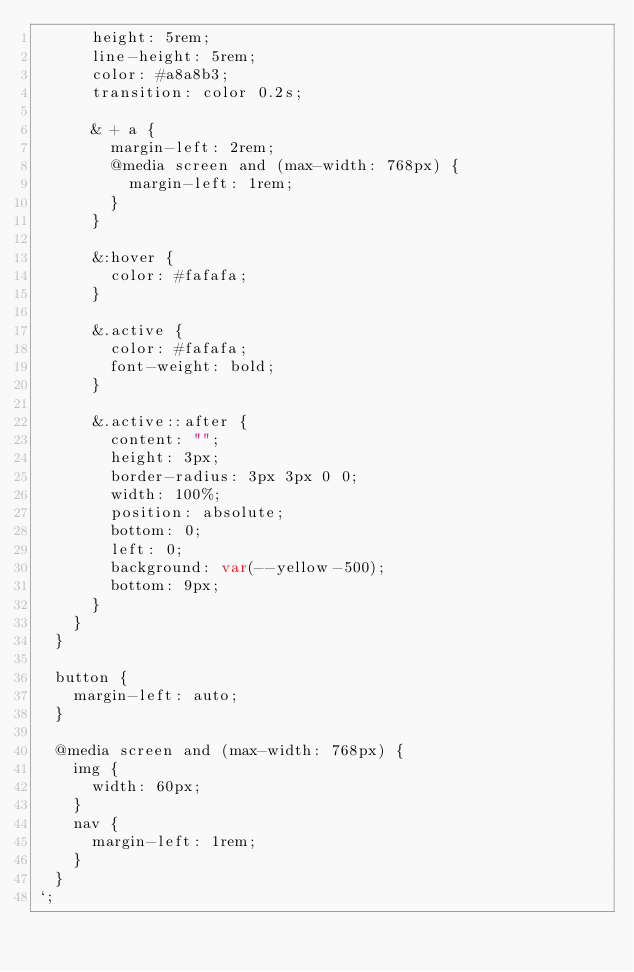<code> <loc_0><loc_0><loc_500><loc_500><_TypeScript_>      height: 5rem;
      line-height: 5rem;
      color: #a8a8b3;
      transition: color 0.2s;

      & + a {
        margin-left: 2rem;
        @media screen and (max-width: 768px) {
          margin-left: 1rem;
        }
      }

      &:hover {
        color: #fafafa;
      }

      &.active {
        color: #fafafa;
        font-weight: bold;
      }

      &.active::after {
        content: "";
        height: 3px;
        border-radius: 3px 3px 0 0;
        width: 100%;
        position: absolute;
        bottom: 0;
        left: 0;
        background: var(--yellow-500);
        bottom: 9px;
      }
    }
  }

  button {
    margin-left: auto;
  }

  @media screen and (max-width: 768px) {
    img {
      width: 60px;
    }
    nav {
      margin-left: 1rem;
    }
  }
`;
</code> 